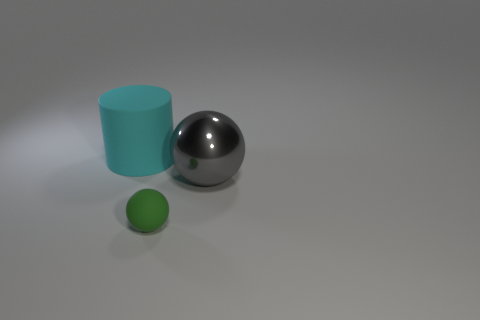Add 1 big matte cylinders. How many objects exist? 4 Subtract all balls. How many objects are left? 1 Subtract 0 brown cylinders. How many objects are left? 3 Subtract all big purple metallic cylinders. Subtract all rubber things. How many objects are left? 1 Add 3 cyan rubber things. How many cyan rubber things are left? 4 Add 1 green balls. How many green balls exist? 2 